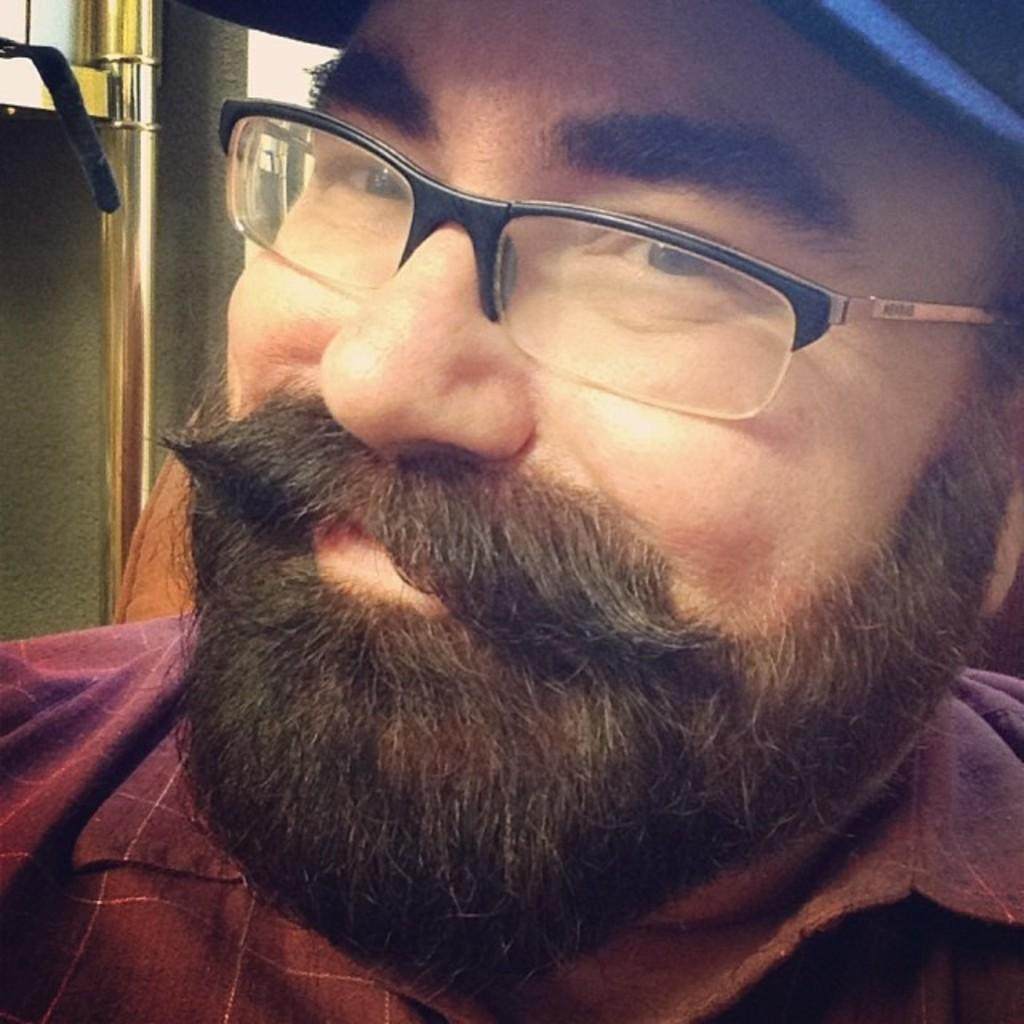What is the main subject of the image? The main subject of the image is a man. Can you describe the man's clothing in the image? The man is wearing a shirt and a cap on his head. What accessories is the man wearing in the image? The man is wearing spectacles. What is the man's facial expression in the image? The man is smiling. What is the man doing in the image? The man is giving a pose for the picture. What can be seen in the background of the image? There is a metal stand in the background of the image. How many boats can be seen in the image? There are no boats present in the image. What type of bone is visible in the man's hand in the image? There is no bone visible in the man's hand in the image. 